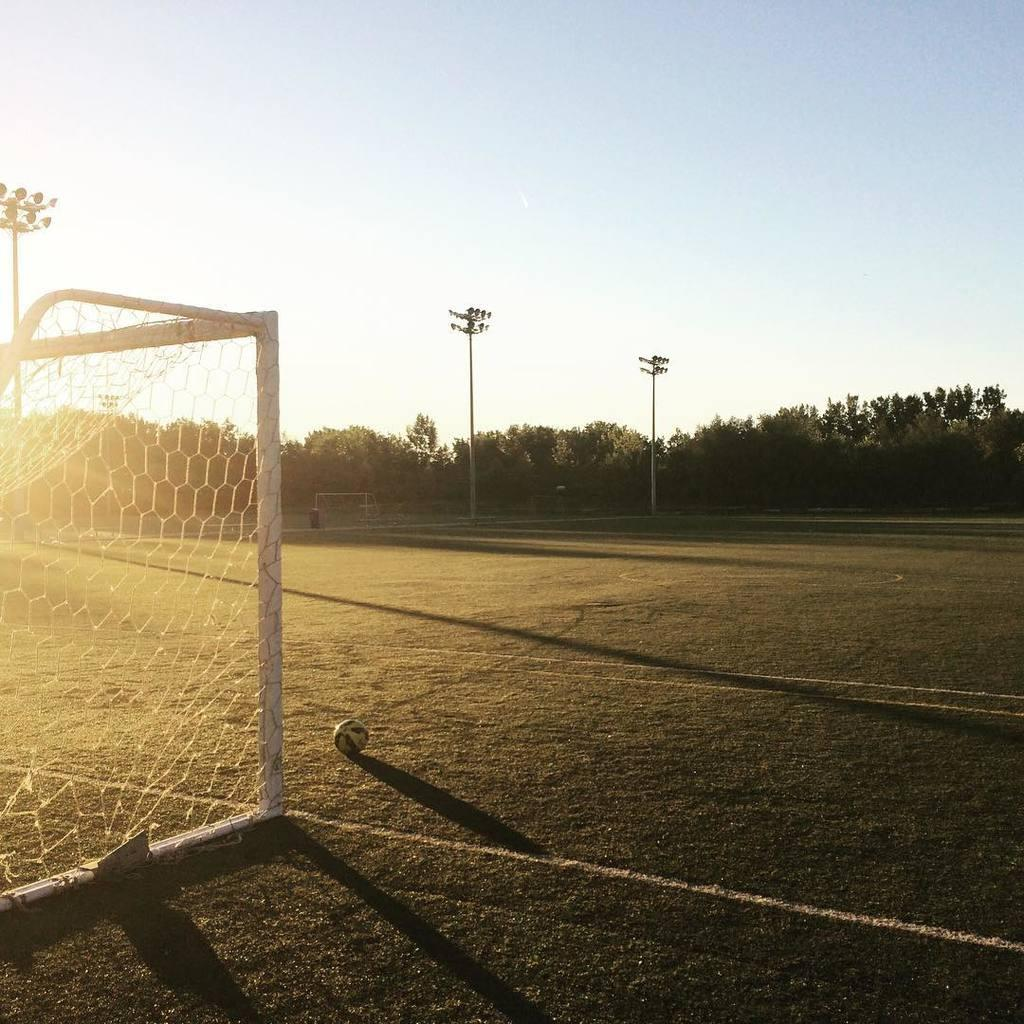What is attached to the pole in the image? There is a net attached to the pole in the image. What object is present near the net? There is a ball in the image. What can be seen in the background of the image? There are light poles and trees with green color in the background of the image. What is visible in the sky in the image? The sky is visible in the image, with a combination of white and blue colors. What type of floor can be seen in the image? There is no floor visible in the image; it appears to be an outdoor scene with a net, pole, ball, and natural elements in the background. What attraction is present in the image? There is no specific attraction mentioned or depicted in the image; it shows a net, pole, ball, and natural elements in the background. 